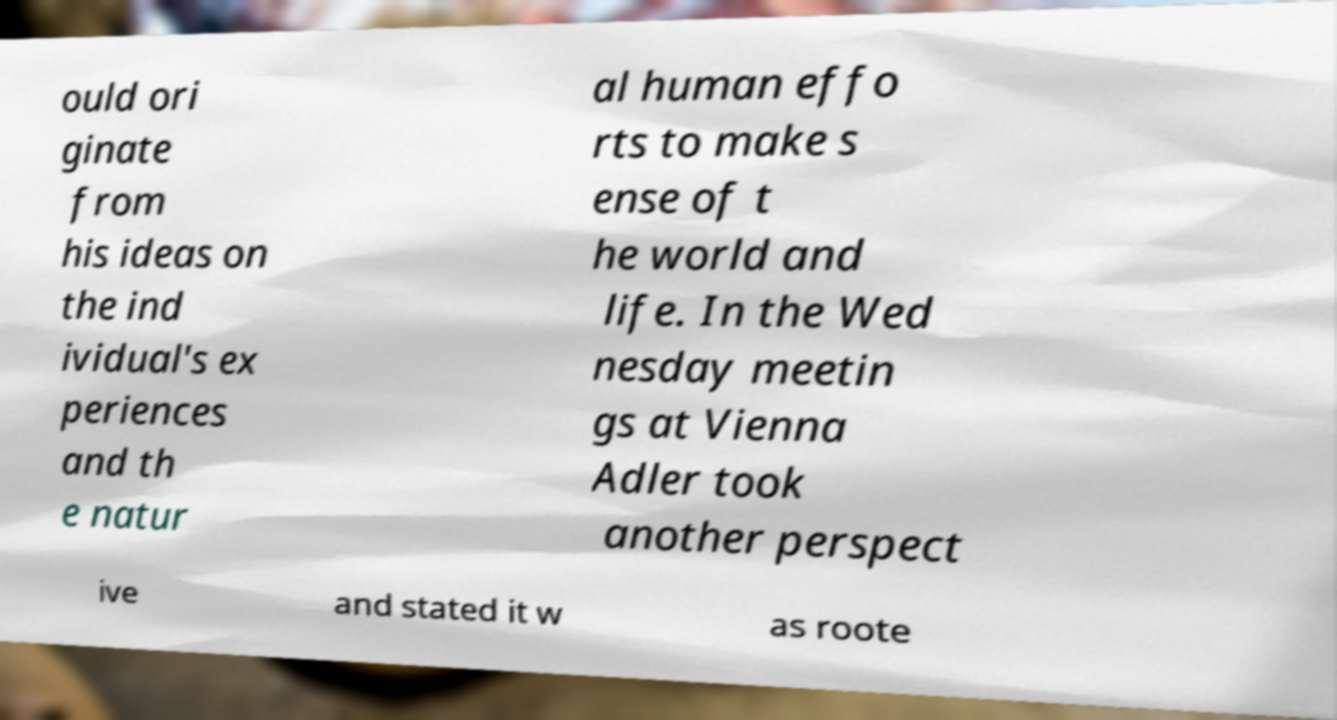I need the written content from this picture converted into text. Can you do that? ould ori ginate from his ideas on the ind ividual's ex periences and th e natur al human effo rts to make s ense of t he world and life. In the Wed nesday meetin gs at Vienna Adler took another perspect ive and stated it w as roote 